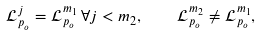<formula> <loc_0><loc_0><loc_500><loc_500>\mathcal { L } ^ { j } _ { p _ { o } } = \mathcal { L } ^ { m _ { 1 } } _ { p _ { o } } \, \forall j < m _ { 2 } , \quad \mathcal { L } ^ { m _ { 2 } } _ { p _ { o } } \neq \mathcal { L } ^ { m _ { 1 } } _ { p _ { o } } ,</formula> 